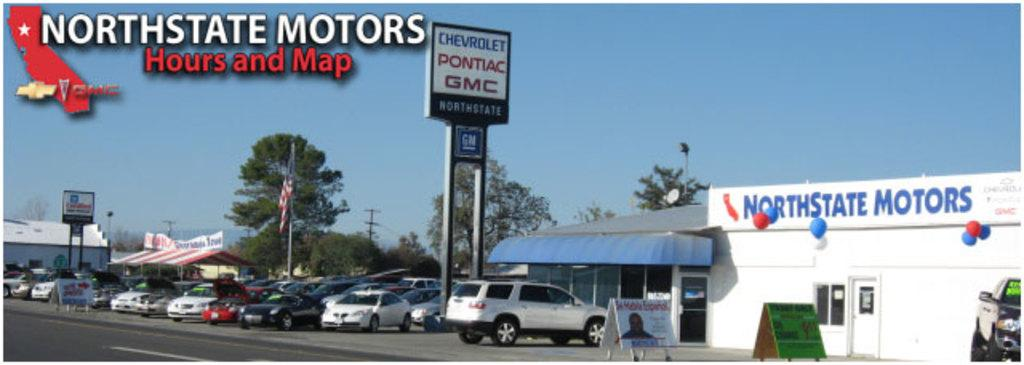What can be seen in the image that is used for transportation? There are vehicles parked in the image. What is the main surface visible in the image? There is a road visible in the image. What type of structures can be seen in the background of the image? There are boards, trees, and sheds in the background of the image. What is visible at the top of the image? The sky is clear and visible at the top of the image by mentioning the presence of the road and the vehicles parked on it. Can you see any fish swimming in the image? There are no fish visible in the image. What type of cactus is present in the image? There is no cactus present in the image. 